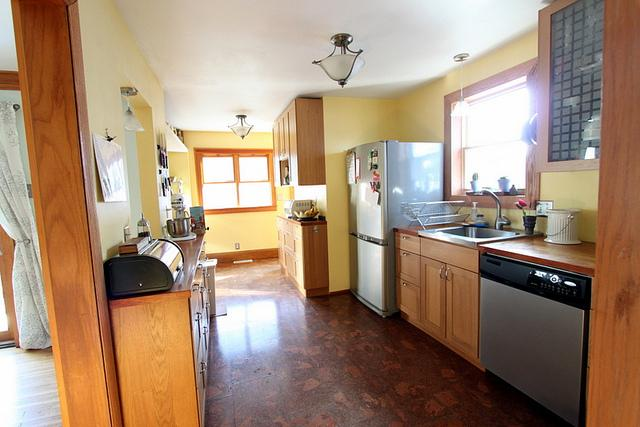What is the rolltop object used for? bread 